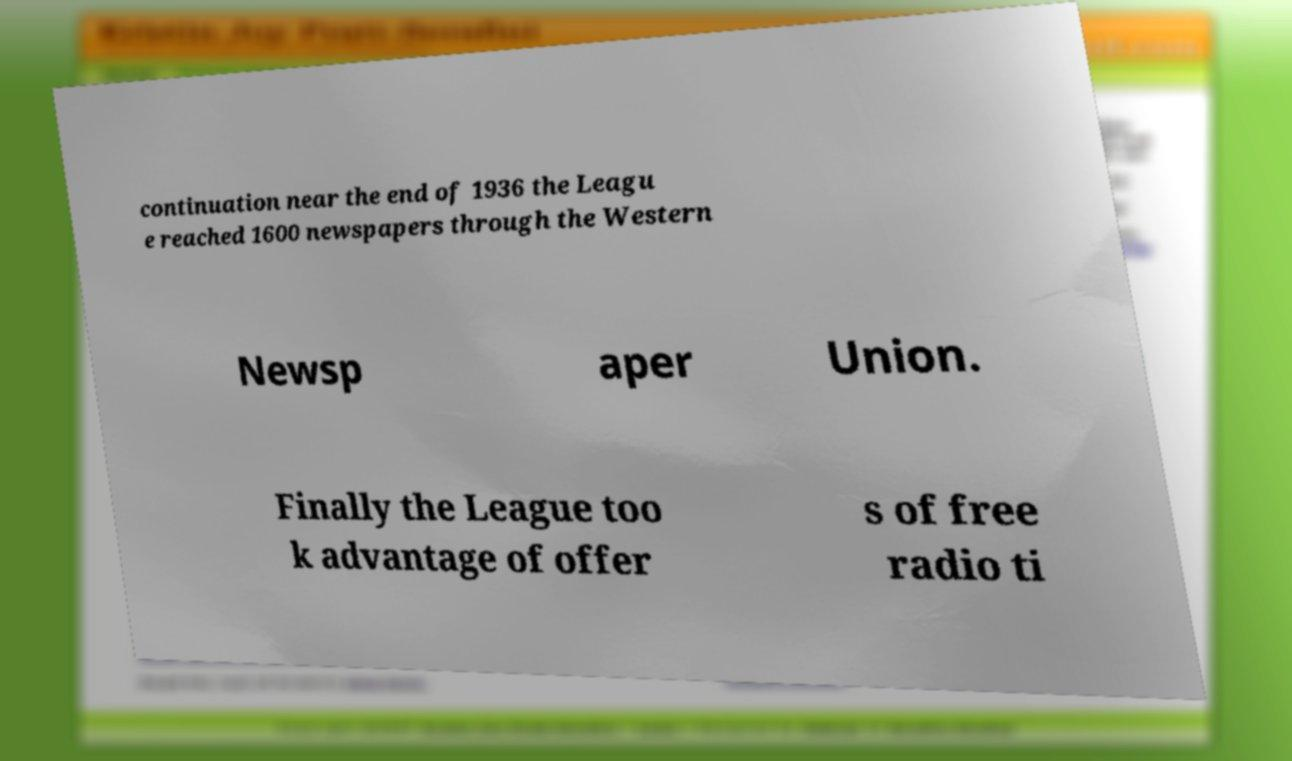Please identify and transcribe the text found in this image. continuation near the end of 1936 the Leagu e reached 1600 newspapers through the Western Newsp aper Union. Finally the League too k advantage of offer s of free radio ti 